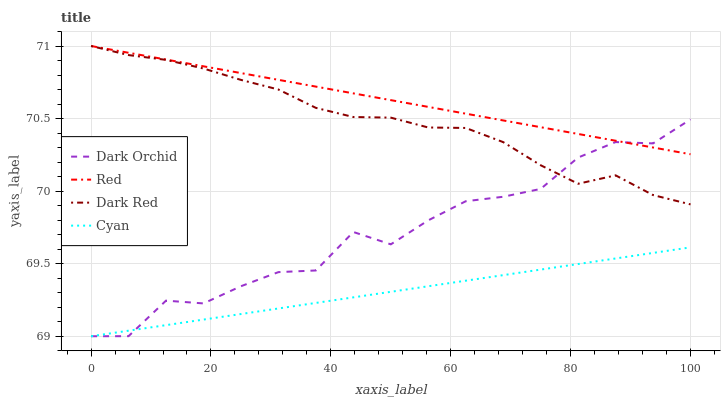Does Cyan have the minimum area under the curve?
Answer yes or no. Yes. Does Red have the maximum area under the curve?
Answer yes or no. Yes. Does Dark Orchid have the minimum area under the curve?
Answer yes or no. No. Does Dark Orchid have the maximum area under the curve?
Answer yes or no. No. Is Red the smoothest?
Answer yes or no. Yes. Is Dark Orchid the roughest?
Answer yes or no. Yes. Is Dark Orchid the smoothest?
Answer yes or no. No. Is Red the roughest?
Answer yes or no. No. Does Red have the lowest value?
Answer yes or no. No. Does Red have the highest value?
Answer yes or no. Yes. Does Dark Orchid have the highest value?
Answer yes or no. No. Is Cyan less than Red?
Answer yes or no. Yes. Is Red greater than Cyan?
Answer yes or no. Yes. Does Cyan intersect Red?
Answer yes or no. No. 